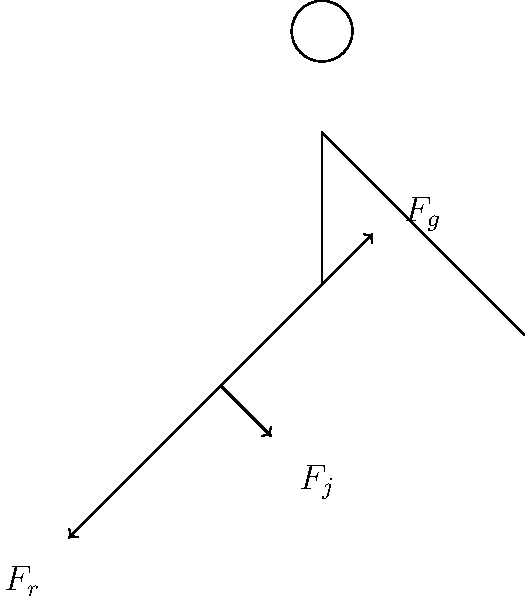During a bicycle kick, which joint experiences the greatest force, and why is this knowledge crucial for preventing injuries in young football players? To answer this question, let's analyze the forces acting on the player's joints during a bicycle kick:

1. Gravity ($F_g$): Acts downward on the entire body, centered at the hip.

2. Joint reaction force ($F_j$): Occurs at the knee joint, counteracting the weight of the lower leg and foot.

3. Reaction force ($F_r$): Generated at the ankle when the foot makes contact with the ball.

The knee joint experiences the greatest force during a bicycle kick for several reasons:

a) It bears the weight of the lower leg and foot.
b) It acts as a fulcrum for the powerful kicking motion.
c) It experiences sudden acceleration and deceleration during the kick.

The force on the knee can be calculated using the equation:

$$F_{knee} = F_g + F_j + F_r \cdot \cos(\theta)$$

Where $\theta$ is the angle between the lower leg and the ground at the moment of impact.

This knowledge is crucial for preventing injuries in young football players because:

1. It helps coaches design appropriate strength and conditioning exercises targeting the knee joint and surrounding muscles.
2. It emphasizes the importance of proper technique to minimize stress on the knee.
3. It guides the development of age-appropriate training programs that gradually increase the intensity of acrobatic moves like bicycle kicks.
4. It informs coaches about the need for adequate warm-up and cool-down routines focused on knee joint mobility and stability.
5. It highlights the importance of rest and recovery to prevent overuse injuries in young athletes.

By understanding the biomechanics of a bicycle kick, coaches can better prepare their young players for advanced techniques while minimizing the risk of injuries.
Answer: Knee joint; crucial for injury prevention through targeted training and technique improvement. 